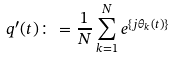<formula> <loc_0><loc_0><loc_500><loc_500>q ^ { \prime } ( t ) \colon = \frac { 1 } { N } \sum _ { k = 1 } ^ { N } e ^ { \{ j \theta _ { k } ( t ) \} }</formula> 